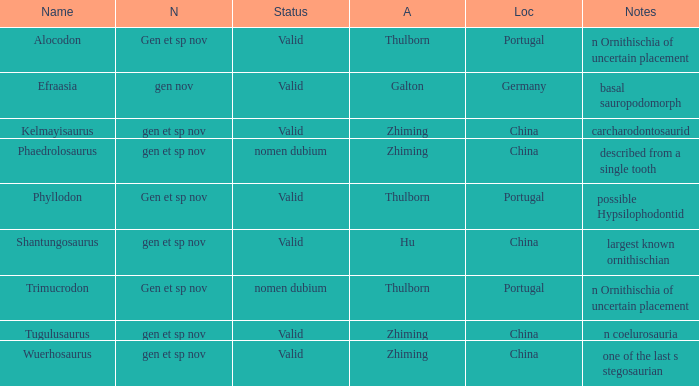What is the Novelty of the dinosaur, whose naming Author was Galton? Gen nov. 